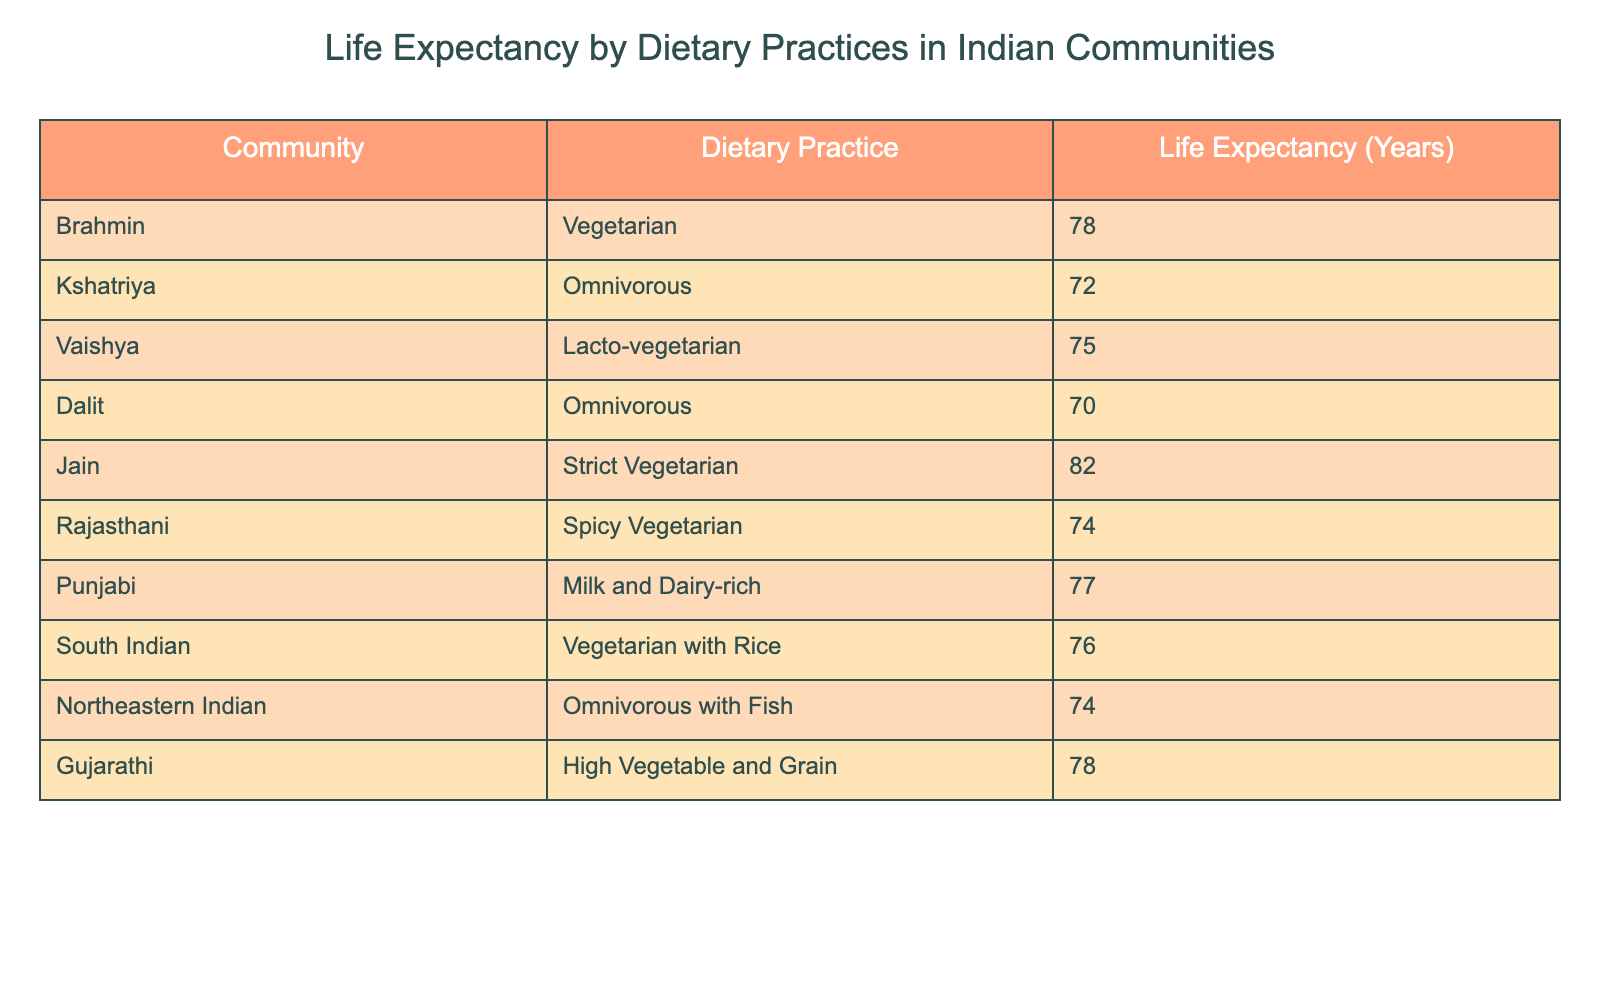What is the life expectancy of the Jain community? The life expectancy of the Jain community as per the table is 82 years.
Answer: 82 Which dietary practice has the highest life expectancy? The Jain community follows a strict vegetarian dietary practice and has the highest life expectancy of 82 years.
Answer: Jain, Strict Vegetarian, 82 What is the average life expectancy of communities practicing omnivorous diets? There are three communities with omnivorous diets: Kshatriya (72), Dalit (70), and Northeastern Indian (74). The sum is 72 + 70 + 74 = 216, and the average is 216 / 3 = 72.
Answer: 72 Is the life expectancy of the Brahmin community higher than that of the Dalit community? The life expectancy of the Brahmin community is 78 years, while the Dalit's is 70 years. Since 78 is greater than 70, the statement is true.
Answer: Yes How much longer do Jains live compared to Kshatriyas? The life expectancy of Jains is 82 years and that of Kshatriyas is 72 years. The difference is 82 - 72 = 10 years.
Answer: 10 years What is the life expectancy of the Punjabis and how does it compare to the average life expectancy of the vegetarian communities? The life expectancy of Punjabis is 77 years, and the vegetarian communities are Brahmin (78), Jain (82), Rajasthani (74), South Indian (76). The sum is 78 + 82 + 74 + 76 = 310 for 4 communities, resulting in an average of 310 / 4 = 77.5. Punjabis live 77 years which is slightly below the vegetarian average of 77.5 years.
Answer: Below average Which community has the lowest life expectancy? The Dalit community has the lowest life expectancy at 70 years.
Answer: 70 What is the total life expectancy of the communities with a lacto-vegetarian diet? The Vaishya community practices lacto-vegetarianism and their life expectancy is 75 years. This is the only data point for this dietary practice in the table.
Answer: 75 What is the life expectancy difference between the Gujarathi and Rajasthani communities? The Gujarathi community has a life expectancy of 78 years and the Rajasthani community has 74 years. The difference is 78 - 74 = 4 years.
Answer: 4 years 